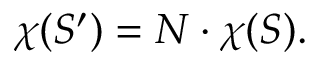<formula> <loc_0><loc_0><loc_500><loc_500>\chi ( S ^ { \prime } ) = N \cdot \chi ( S ) .</formula> 